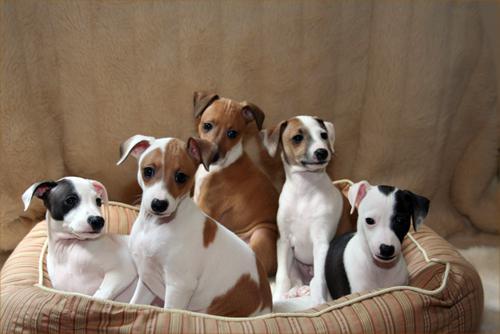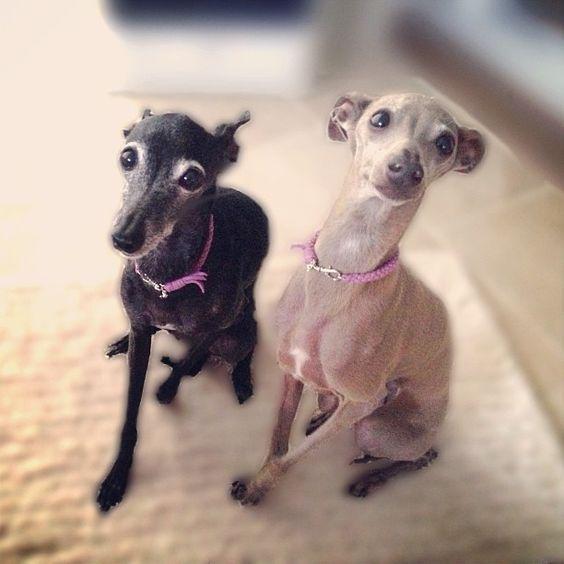The first image is the image on the left, the second image is the image on the right. For the images displayed, is the sentence "An image shows at least three dogs inside some type of container." factually correct? Answer yes or no. Yes. The first image is the image on the left, the second image is the image on the right. Analyze the images presented: Is the assertion "At least three four dogs are sitting down." valid? Answer yes or no. Yes. 